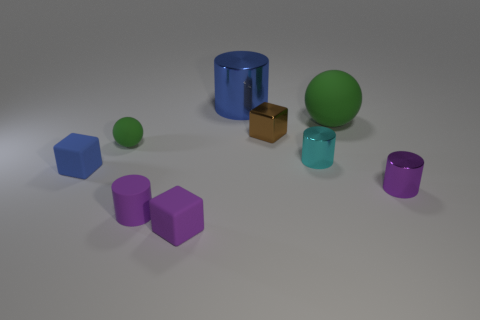Subtract all purple rubber cubes. How many cubes are left? 2 Subtract all blue cubes. How many cubes are left? 2 Subtract all cubes. How many objects are left? 6 Subtract 3 cylinders. How many cylinders are left? 1 Subtract all cyan balls. Subtract all yellow cylinders. How many balls are left? 2 Subtract all red spheres. How many purple cylinders are left? 2 Subtract all large green things. Subtract all large cyan balls. How many objects are left? 8 Add 4 big blue things. How many big blue things are left? 5 Add 6 small cyan shiny things. How many small cyan shiny things exist? 7 Subtract 0 red cylinders. How many objects are left? 9 